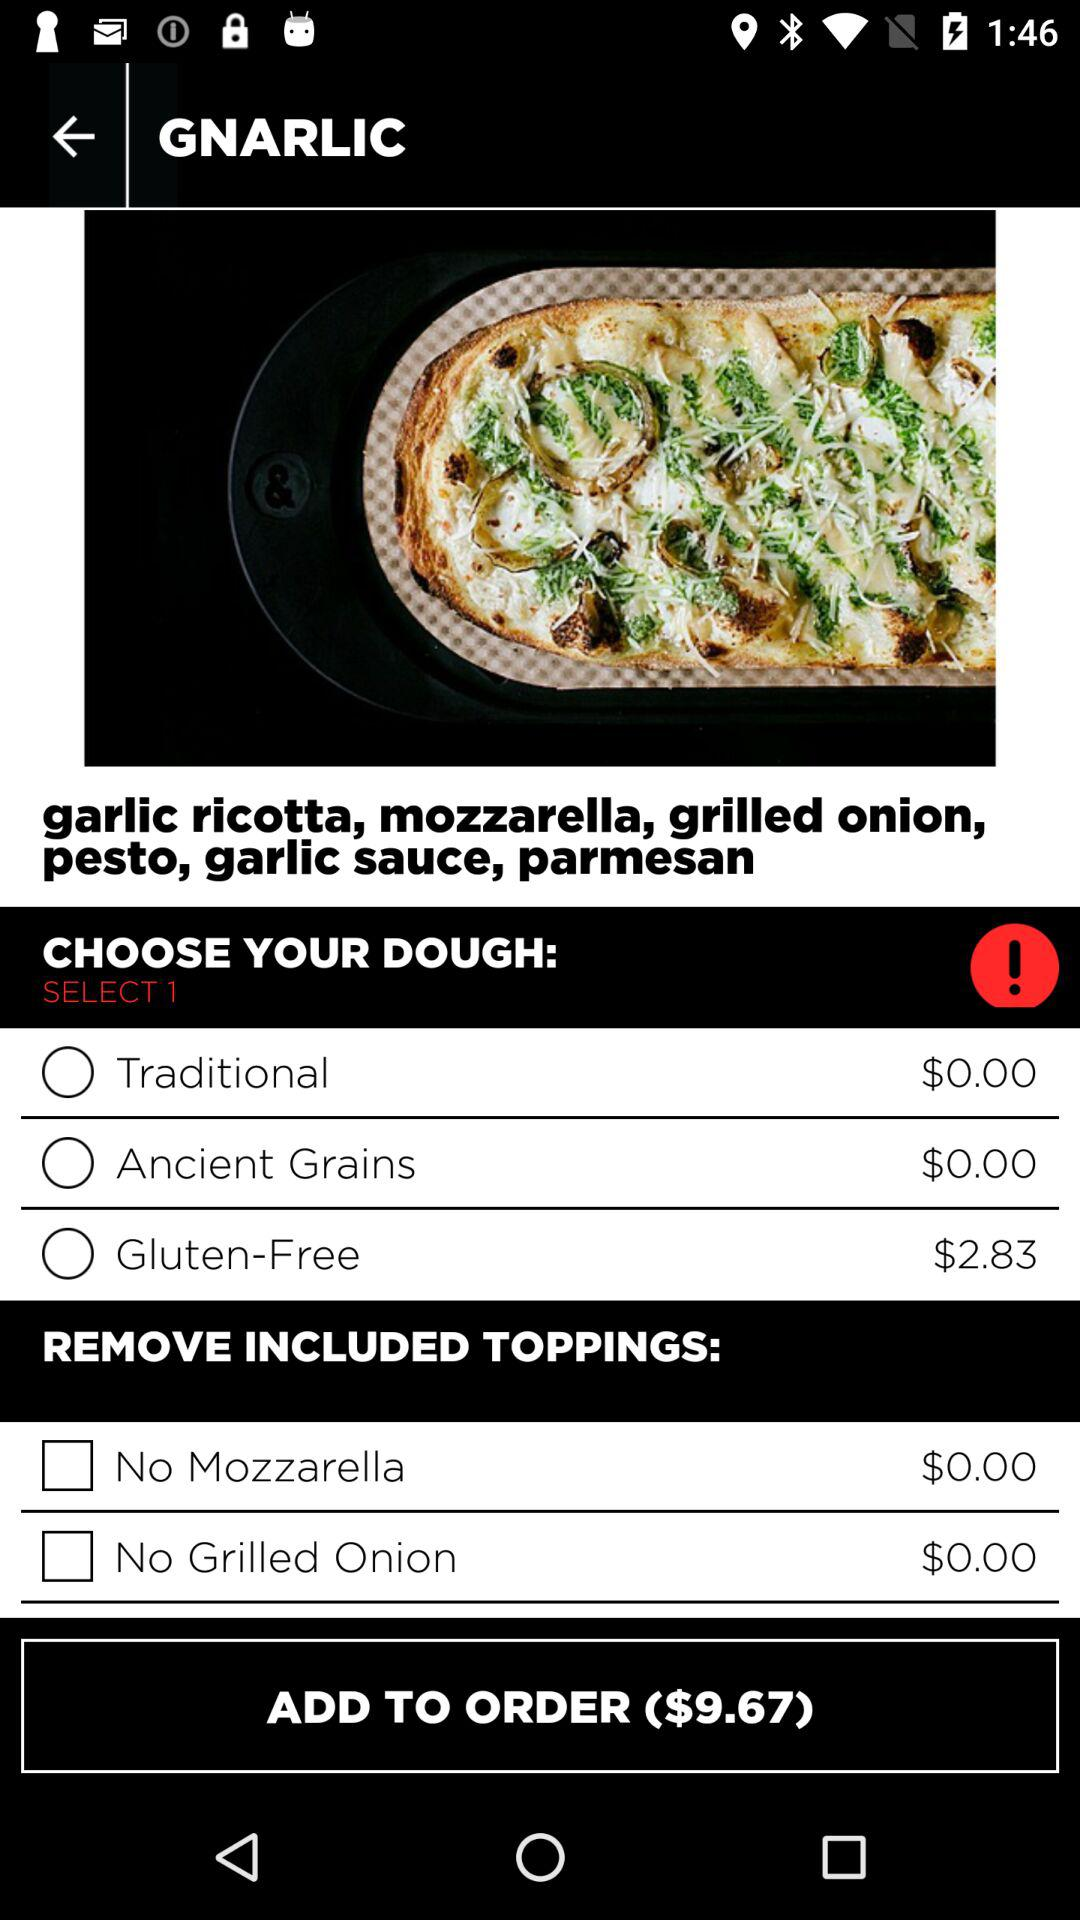What are the ingredients used in "GNARLIC"? The used ingredients are garlic ricotta, mozzarella, grilled onion, pesto, garlic sauce and parmesan. 